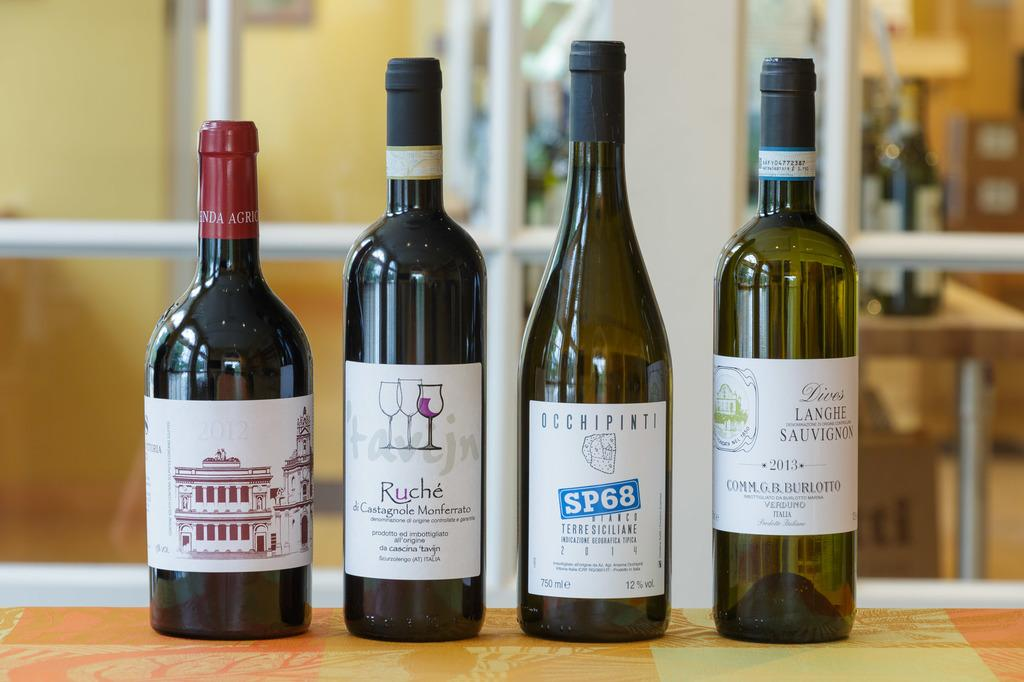<image>
Give a short and clear explanation of the subsequent image. Four wine bottles are in a row and one of them is called Ruche. 